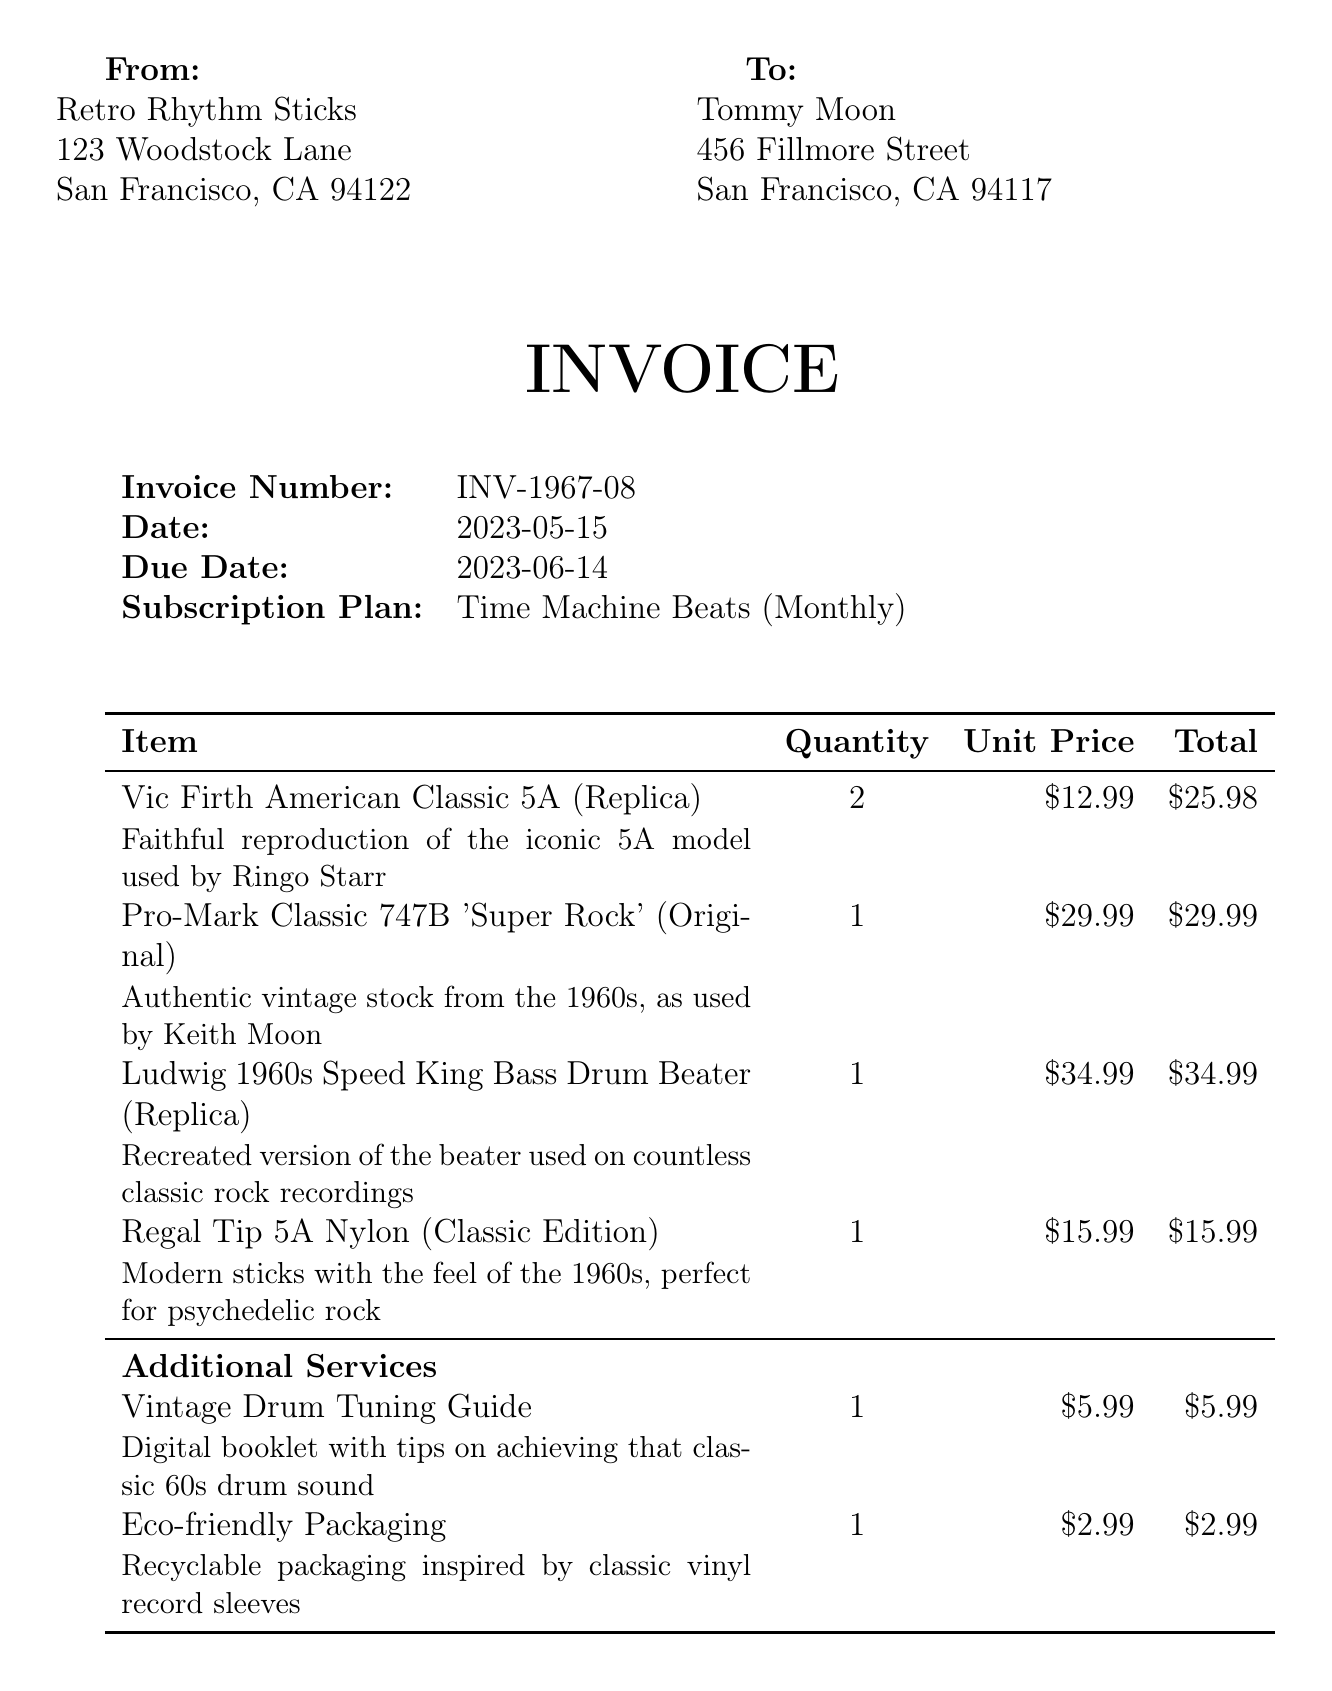What is the invoice number? The invoice number is listed in the document as INV-1967-08.
Answer: INV-1967-08 Who is the customer? The document specifies that the customer is Tommy Moon.
Answer: Tommy Moon What is the total amount due? The total amount due is clearly stated at the bottom of the invoice as $125.30.
Answer: $125.30 How many items are included in the subscription? There are four items listed under subscription items in the invoice.
Answer: Four What is the shipping cost? The shipping cost is explicitly mentioned as $8.99 in the invoice.
Answer: $8.99 What subscription plan is mentioned? The subscription plan is referred to as Time Machine Beats in the document.
Answer: Time Machine Beats What is included in the additional services? The additional services include Vintage Drum Tuning Guide and Eco-friendly Packaging.
Answer: Vintage Drum Tuning Guide, Eco-friendly Packaging When is the payment due? The due date for payment is noted as June 14, 2023.
Answer: June 14, 2023 What is the customer support email address? The customer support email address is provided as groove@retrorhythmsticks.com.
Answer: groove@retrorhythmsticks.com 